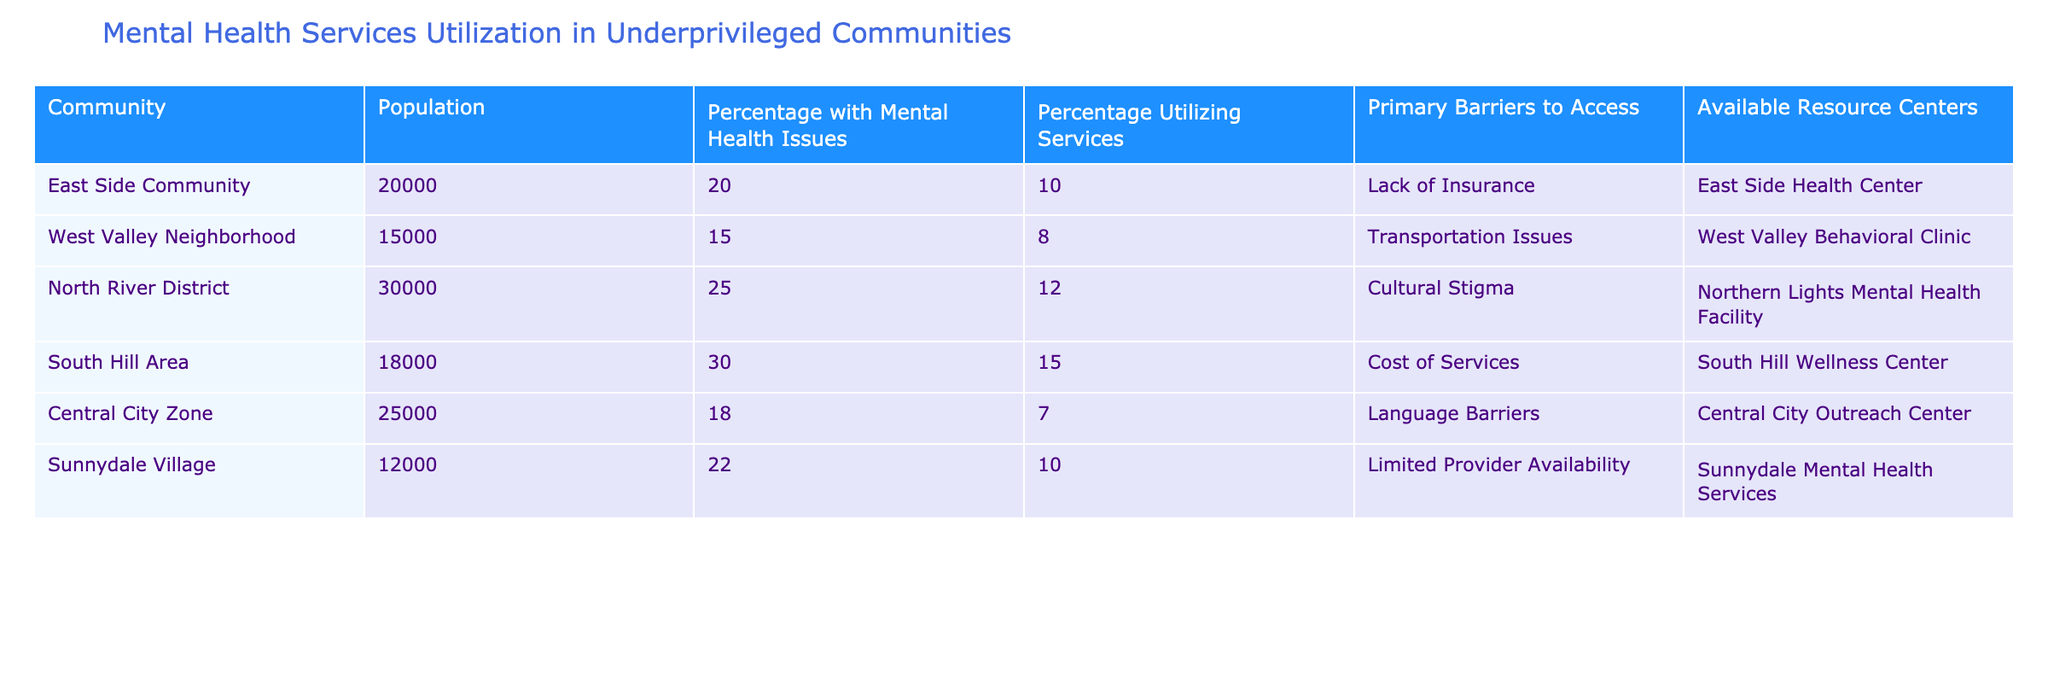What is the percentage of individuals utilizing mental health services in the East Side Community? The table indicates that 10% of individuals in the East Side Community utilize mental health services. This is directly stated in the "Percentage Utilizing Services" column for this community.
Answer: 10% Which community has the highest percentage of people with mental health issues? By looking at the "Percentage with Mental Health Issues" column, North River District has the highest value at 25%. Each community's percentage can be compared to find the maximum.
Answer: North River District What is the average percentage of individuals utilizing mental health services across all communities? To find the average, we sum the percentages utilizing services for all communities (10% + 8% + 12% + 15% + 7% + 10% = 62%), divide by the number of communities (6), yielding an average of 10.33%.
Answer: 10.33% Is there a community where the percentage of individuals utilizing services is higher than the percentage of individuals with mental health issues? Analyzing the table, no community shows a higher percentage of utilization compared to issues. For example, the South Hill Area has 30% with issues but only 15% utilizing services.
Answer: No What is the primary barrier to accessing services for the community with the lowest percentage of utilization? The Central City Zone has the lowest utilization rate at 7%, and its primary barrier is "Language Barriers," as indicated in the corresponding column.
Answer: Language Barriers If the South Hill Area improved service utilization by 10%, what would the new percentage be? The South Hill Area currently has a utilization percentage of 15%. Adding 10% would result in a new value of 25%. This is a simple addition calculation.
Answer: 25% Which community has the most available resource centers? Reviewing the table, each community is listed with one resource center, implying they all have the same number. Therefore, there is no community with more resource centers than others.
Answer: All communities have one resource center What percentage of individuals with mental health issues does the West Valley Neighborhood utilize? The West Valley Neighborhood has a utilization rate of 8%, while it has 15% of its population reporting mental health issues. This percentage is specified in the table directly.
Answer: 8% 